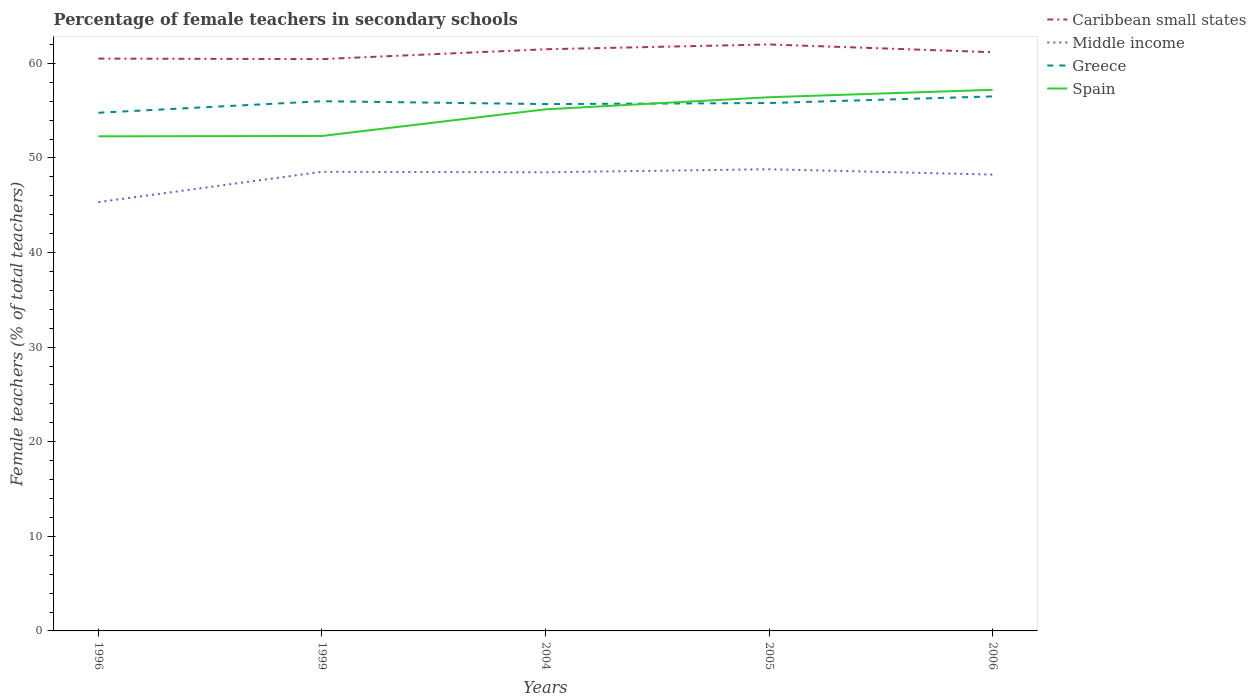Does the line corresponding to Greece intersect with the line corresponding to Spain?
Your answer should be very brief. Yes. Is the number of lines equal to the number of legend labels?
Make the answer very short. Yes. Across all years, what is the maximum percentage of female teachers in Caribbean small states?
Give a very brief answer. 60.45. In which year was the percentage of female teachers in Spain maximum?
Offer a very short reply. 1996. What is the total percentage of female teachers in Middle income in the graph?
Make the answer very short. 0.05. What is the difference between the highest and the second highest percentage of female teachers in Spain?
Make the answer very short. 4.92. What is the difference between the highest and the lowest percentage of female teachers in Middle income?
Your response must be concise. 4. Is the percentage of female teachers in Caribbean small states strictly greater than the percentage of female teachers in Spain over the years?
Your answer should be very brief. No. How many lines are there?
Provide a succinct answer. 4. How many years are there in the graph?
Offer a terse response. 5. Are the values on the major ticks of Y-axis written in scientific E-notation?
Keep it short and to the point. No. Does the graph contain any zero values?
Provide a succinct answer. No. Does the graph contain grids?
Ensure brevity in your answer.  No. How many legend labels are there?
Give a very brief answer. 4. How are the legend labels stacked?
Your answer should be compact. Vertical. What is the title of the graph?
Offer a very short reply. Percentage of female teachers in secondary schools. What is the label or title of the X-axis?
Your response must be concise. Years. What is the label or title of the Y-axis?
Your response must be concise. Female teachers (% of total teachers). What is the Female teachers (% of total teachers) in Caribbean small states in 1996?
Offer a terse response. 60.5. What is the Female teachers (% of total teachers) in Middle income in 1996?
Offer a very short reply. 45.33. What is the Female teachers (% of total teachers) in Greece in 1996?
Provide a succinct answer. 54.78. What is the Female teachers (% of total teachers) of Spain in 1996?
Offer a very short reply. 52.28. What is the Female teachers (% of total teachers) of Caribbean small states in 1999?
Ensure brevity in your answer.  60.45. What is the Female teachers (% of total teachers) in Middle income in 1999?
Keep it short and to the point. 48.54. What is the Female teachers (% of total teachers) in Greece in 1999?
Your answer should be very brief. 56. What is the Female teachers (% of total teachers) in Spain in 1999?
Offer a terse response. 52.32. What is the Female teachers (% of total teachers) of Caribbean small states in 2004?
Make the answer very short. 61.49. What is the Female teachers (% of total teachers) of Middle income in 2004?
Keep it short and to the point. 48.48. What is the Female teachers (% of total teachers) of Greece in 2004?
Your answer should be compact. 55.69. What is the Female teachers (% of total teachers) in Spain in 2004?
Your response must be concise. 55.14. What is the Female teachers (% of total teachers) in Caribbean small states in 2005?
Your answer should be very brief. 62. What is the Female teachers (% of total teachers) of Middle income in 2005?
Provide a short and direct response. 48.81. What is the Female teachers (% of total teachers) of Greece in 2005?
Make the answer very short. 55.8. What is the Female teachers (% of total teachers) of Spain in 2005?
Ensure brevity in your answer.  56.42. What is the Female teachers (% of total teachers) of Caribbean small states in 2006?
Your response must be concise. 61.18. What is the Female teachers (% of total teachers) in Middle income in 2006?
Give a very brief answer. 48.24. What is the Female teachers (% of total teachers) of Greece in 2006?
Keep it short and to the point. 56.5. What is the Female teachers (% of total teachers) in Spain in 2006?
Your answer should be very brief. 57.2. Across all years, what is the maximum Female teachers (% of total teachers) in Caribbean small states?
Make the answer very short. 62. Across all years, what is the maximum Female teachers (% of total teachers) of Middle income?
Ensure brevity in your answer.  48.81. Across all years, what is the maximum Female teachers (% of total teachers) in Greece?
Offer a very short reply. 56.5. Across all years, what is the maximum Female teachers (% of total teachers) of Spain?
Make the answer very short. 57.2. Across all years, what is the minimum Female teachers (% of total teachers) in Caribbean small states?
Give a very brief answer. 60.45. Across all years, what is the minimum Female teachers (% of total teachers) of Middle income?
Ensure brevity in your answer.  45.33. Across all years, what is the minimum Female teachers (% of total teachers) of Greece?
Make the answer very short. 54.78. Across all years, what is the minimum Female teachers (% of total teachers) in Spain?
Your answer should be compact. 52.28. What is the total Female teachers (% of total teachers) of Caribbean small states in the graph?
Offer a terse response. 305.61. What is the total Female teachers (% of total teachers) in Middle income in the graph?
Your response must be concise. 239.39. What is the total Female teachers (% of total teachers) in Greece in the graph?
Provide a short and direct response. 278.77. What is the total Female teachers (% of total teachers) of Spain in the graph?
Your response must be concise. 273.36. What is the difference between the Female teachers (% of total teachers) in Caribbean small states in 1996 and that in 1999?
Your answer should be compact. 0.05. What is the difference between the Female teachers (% of total teachers) in Middle income in 1996 and that in 1999?
Your answer should be very brief. -3.2. What is the difference between the Female teachers (% of total teachers) in Greece in 1996 and that in 1999?
Make the answer very short. -1.22. What is the difference between the Female teachers (% of total teachers) of Spain in 1996 and that in 1999?
Offer a terse response. -0.04. What is the difference between the Female teachers (% of total teachers) of Caribbean small states in 1996 and that in 2004?
Offer a terse response. -0.99. What is the difference between the Female teachers (% of total teachers) in Middle income in 1996 and that in 2004?
Your answer should be very brief. -3.15. What is the difference between the Female teachers (% of total teachers) in Greece in 1996 and that in 2004?
Keep it short and to the point. -0.92. What is the difference between the Female teachers (% of total teachers) in Spain in 1996 and that in 2004?
Provide a succinct answer. -2.85. What is the difference between the Female teachers (% of total teachers) of Caribbean small states in 1996 and that in 2005?
Offer a terse response. -1.5. What is the difference between the Female teachers (% of total teachers) in Middle income in 1996 and that in 2005?
Your answer should be compact. -3.48. What is the difference between the Female teachers (% of total teachers) of Greece in 1996 and that in 2005?
Make the answer very short. -1.03. What is the difference between the Female teachers (% of total teachers) of Spain in 1996 and that in 2005?
Provide a succinct answer. -4.13. What is the difference between the Female teachers (% of total teachers) of Caribbean small states in 1996 and that in 2006?
Make the answer very short. -0.68. What is the difference between the Female teachers (% of total teachers) in Middle income in 1996 and that in 2006?
Your response must be concise. -2.91. What is the difference between the Female teachers (% of total teachers) of Greece in 1996 and that in 2006?
Provide a short and direct response. -1.73. What is the difference between the Female teachers (% of total teachers) of Spain in 1996 and that in 2006?
Your response must be concise. -4.92. What is the difference between the Female teachers (% of total teachers) of Caribbean small states in 1999 and that in 2004?
Your answer should be very brief. -1.04. What is the difference between the Female teachers (% of total teachers) in Middle income in 1999 and that in 2004?
Offer a very short reply. 0.05. What is the difference between the Female teachers (% of total teachers) of Greece in 1999 and that in 2004?
Provide a short and direct response. 0.3. What is the difference between the Female teachers (% of total teachers) of Spain in 1999 and that in 2004?
Provide a short and direct response. -2.81. What is the difference between the Female teachers (% of total teachers) of Caribbean small states in 1999 and that in 2005?
Make the answer very short. -1.55. What is the difference between the Female teachers (% of total teachers) in Middle income in 1999 and that in 2005?
Provide a succinct answer. -0.27. What is the difference between the Female teachers (% of total teachers) in Greece in 1999 and that in 2005?
Make the answer very short. 0.19. What is the difference between the Female teachers (% of total teachers) in Spain in 1999 and that in 2005?
Keep it short and to the point. -4.09. What is the difference between the Female teachers (% of total teachers) in Caribbean small states in 1999 and that in 2006?
Your response must be concise. -0.73. What is the difference between the Female teachers (% of total teachers) in Middle income in 1999 and that in 2006?
Provide a short and direct response. 0.3. What is the difference between the Female teachers (% of total teachers) of Greece in 1999 and that in 2006?
Offer a very short reply. -0.51. What is the difference between the Female teachers (% of total teachers) in Spain in 1999 and that in 2006?
Provide a short and direct response. -4.88. What is the difference between the Female teachers (% of total teachers) of Caribbean small states in 2004 and that in 2005?
Keep it short and to the point. -0.51. What is the difference between the Female teachers (% of total teachers) of Middle income in 2004 and that in 2005?
Ensure brevity in your answer.  -0.32. What is the difference between the Female teachers (% of total teachers) in Greece in 2004 and that in 2005?
Give a very brief answer. -0.11. What is the difference between the Female teachers (% of total teachers) of Spain in 2004 and that in 2005?
Your answer should be compact. -1.28. What is the difference between the Female teachers (% of total teachers) of Caribbean small states in 2004 and that in 2006?
Provide a succinct answer. 0.31. What is the difference between the Female teachers (% of total teachers) of Middle income in 2004 and that in 2006?
Provide a short and direct response. 0.24. What is the difference between the Female teachers (% of total teachers) in Greece in 2004 and that in 2006?
Provide a succinct answer. -0.81. What is the difference between the Female teachers (% of total teachers) of Spain in 2004 and that in 2006?
Provide a succinct answer. -2.06. What is the difference between the Female teachers (% of total teachers) of Caribbean small states in 2005 and that in 2006?
Your response must be concise. 0.82. What is the difference between the Female teachers (% of total teachers) in Middle income in 2005 and that in 2006?
Give a very brief answer. 0.57. What is the difference between the Female teachers (% of total teachers) in Greece in 2005 and that in 2006?
Ensure brevity in your answer.  -0.7. What is the difference between the Female teachers (% of total teachers) in Spain in 2005 and that in 2006?
Your answer should be compact. -0.79. What is the difference between the Female teachers (% of total teachers) of Caribbean small states in 1996 and the Female teachers (% of total teachers) of Middle income in 1999?
Keep it short and to the point. 11.97. What is the difference between the Female teachers (% of total teachers) of Caribbean small states in 1996 and the Female teachers (% of total teachers) of Greece in 1999?
Provide a short and direct response. 4.5. What is the difference between the Female teachers (% of total teachers) of Caribbean small states in 1996 and the Female teachers (% of total teachers) of Spain in 1999?
Your answer should be very brief. 8.18. What is the difference between the Female teachers (% of total teachers) of Middle income in 1996 and the Female teachers (% of total teachers) of Greece in 1999?
Give a very brief answer. -10.67. What is the difference between the Female teachers (% of total teachers) in Middle income in 1996 and the Female teachers (% of total teachers) in Spain in 1999?
Ensure brevity in your answer.  -6.99. What is the difference between the Female teachers (% of total teachers) in Greece in 1996 and the Female teachers (% of total teachers) in Spain in 1999?
Keep it short and to the point. 2.45. What is the difference between the Female teachers (% of total teachers) of Caribbean small states in 1996 and the Female teachers (% of total teachers) of Middle income in 2004?
Keep it short and to the point. 12.02. What is the difference between the Female teachers (% of total teachers) of Caribbean small states in 1996 and the Female teachers (% of total teachers) of Greece in 2004?
Provide a short and direct response. 4.81. What is the difference between the Female teachers (% of total teachers) of Caribbean small states in 1996 and the Female teachers (% of total teachers) of Spain in 2004?
Your answer should be very brief. 5.36. What is the difference between the Female teachers (% of total teachers) of Middle income in 1996 and the Female teachers (% of total teachers) of Greece in 2004?
Give a very brief answer. -10.36. What is the difference between the Female teachers (% of total teachers) in Middle income in 1996 and the Female teachers (% of total teachers) in Spain in 2004?
Make the answer very short. -9.81. What is the difference between the Female teachers (% of total teachers) of Greece in 1996 and the Female teachers (% of total teachers) of Spain in 2004?
Offer a terse response. -0.36. What is the difference between the Female teachers (% of total teachers) in Caribbean small states in 1996 and the Female teachers (% of total teachers) in Middle income in 2005?
Your answer should be very brief. 11.7. What is the difference between the Female teachers (% of total teachers) in Caribbean small states in 1996 and the Female teachers (% of total teachers) in Greece in 2005?
Offer a very short reply. 4.7. What is the difference between the Female teachers (% of total teachers) in Caribbean small states in 1996 and the Female teachers (% of total teachers) in Spain in 2005?
Make the answer very short. 4.08. What is the difference between the Female teachers (% of total teachers) in Middle income in 1996 and the Female teachers (% of total teachers) in Greece in 2005?
Offer a very short reply. -10.47. What is the difference between the Female teachers (% of total teachers) of Middle income in 1996 and the Female teachers (% of total teachers) of Spain in 2005?
Ensure brevity in your answer.  -11.09. What is the difference between the Female teachers (% of total teachers) in Greece in 1996 and the Female teachers (% of total teachers) in Spain in 2005?
Your answer should be compact. -1.64. What is the difference between the Female teachers (% of total teachers) of Caribbean small states in 1996 and the Female teachers (% of total teachers) of Middle income in 2006?
Keep it short and to the point. 12.26. What is the difference between the Female teachers (% of total teachers) of Caribbean small states in 1996 and the Female teachers (% of total teachers) of Greece in 2006?
Provide a short and direct response. 4. What is the difference between the Female teachers (% of total teachers) of Caribbean small states in 1996 and the Female teachers (% of total teachers) of Spain in 2006?
Keep it short and to the point. 3.3. What is the difference between the Female teachers (% of total teachers) in Middle income in 1996 and the Female teachers (% of total teachers) in Greece in 2006?
Your response must be concise. -11.17. What is the difference between the Female teachers (% of total teachers) of Middle income in 1996 and the Female teachers (% of total teachers) of Spain in 2006?
Offer a very short reply. -11.87. What is the difference between the Female teachers (% of total teachers) in Greece in 1996 and the Female teachers (% of total teachers) in Spain in 2006?
Provide a succinct answer. -2.43. What is the difference between the Female teachers (% of total teachers) of Caribbean small states in 1999 and the Female teachers (% of total teachers) of Middle income in 2004?
Your answer should be compact. 11.97. What is the difference between the Female teachers (% of total teachers) in Caribbean small states in 1999 and the Female teachers (% of total teachers) in Greece in 2004?
Your answer should be compact. 4.76. What is the difference between the Female teachers (% of total teachers) in Caribbean small states in 1999 and the Female teachers (% of total teachers) in Spain in 2004?
Offer a terse response. 5.31. What is the difference between the Female teachers (% of total teachers) of Middle income in 1999 and the Female teachers (% of total teachers) of Greece in 2004?
Provide a succinct answer. -7.16. What is the difference between the Female teachers (% of total teachers) of Middle income in 1999 and the Female teachers (% of total teachers) of Spain in 2004?
Ensure brevity in your answer.  -6.6. What is the difference between the Female teachers (% of total teachers) in Greece in 1999 and the Female teachers (% of total teachers) in Spain in 2004?
Keep it short and to the point. 0.86. What is the difference between the Female teachers (% of total teachers) of Caribbean small states in 1999 and the Female teachers (% of total teachers) of Middle income in 2005?
Keep it short and to the point. 11.64. What is the difference between the Female teachers (% of total teachers) in Caribbean small states in 1999 and the Female teachers (% of total teachers) in Greece in 2005?
Your answer should be very brief. 4.64. What is the difference between the Female teachers (% of total teachers) in Caribbean small states in 1999 and the Female teachers (% of total teachers) in Spain in 2005?
Give a very brief answer. 4.03. What is the difference between the Female teachers (% of total teachers) of Middle income in 1999 and the Female teachers (% of total teachers) of Greece in 2005?
Offer a terse response. -7.27. What is the difference between the Female teachers (% of total teachers) of Middle income in 1999 and the Female teachers (% of total teachers) of Spain in 2005?
Make the answer very short. -7.88. What is the difference between the Female teachers (% of total teachers) of Greece in 1999 and the Female teachers (% of total teachers) of Spain in 2005?
Your response must be concise. -0.42. What is the difference between the Female teachers (% of total teachers) of Caribbean small states in 1999 and the Female teachers (% of total teachers) of Middle income in 2006?
Ensure brevity in your answer.  12.21. What is the difference between the Female teachers (% of total teachers) of Caribbean small states in 1999 and the Female teachers (% of total teachers) of Greece in 2006?
Your response must be concise. 3.94. What is the difference between the Female teachers (% of total teachers) in Caribbean small states in 1999 and the Female teachers (% of total teachers) in Spain in 2006?
Keep it short and to the point. 3.25. What is the difference between the Female teachers (% of total teachers) of Middle income in 1999 and the Female teachers (% of total teachers) of Greece in 2006?
Make the answer very short. -7.97. What is the difference between the Female teachers (% of total teachers) in Middle income in 1999 and the Female teachers (% of total teachers) in Spain in 2006?
Offer a terse response. -8.67. What is the difference between the Female teachers (% of total teachers) of Greece in 1999 and the Female teachers (% of total teachers) of Spain in 2006?
Your answer should be compact. -1.21. What is the difference between the Female teachers (% of total teachers) of Caribbean small states in 2004 and the Female teachers (% of total teachers) of Middle income in 2005?
Offer a very short reply. 12.68. What is the difference between the Female teachers (% of total teachers) in Caribbean small states in 2004 and the Female teachers (% of total teachers) in Greece in 2005?
Keep it short and to the point. 5.68. What is the difference between the Female teachers (% of total teachers) in Caribbean small states in 2004 and the Female teachers (% of total teachers) in Spain in 2005?
Provide a succinct answer. 5.07. What is the difference between the Female teachers (% of total teachers) of Middle income in 2004 and the Female teachers (% of total teachers) of Greece in 2005?
Keep it short and to the point. -7.32. What is the difference between the Female teachers (% of total teachers) of Middle income in 2004 and the Female teachers (% of total teachers) of Spain in 2005?
Provide a succinct answer. -7.93. What is the difference between the Female teachers (% of total teachers) of Greece in 2004 and the Female teachers (% of total teachers) of Spain in 2005?
Offer a terse response. -0.72. What is the difference between the Female teachers (% of total teachers) of Caribbean small states in 2004 and the Female teachers (% of total teachers) of Middle income in 2006?
Keep it short and to the point. 13.25. What is the difference between the Female teachers (% of total teachers) of Caribbean small states in 2004 and the Female teachers (% of total teachers) of Greece in 2006?
Make the answer very short. 4.98. What is the difference between the Female teachers (% of total teachers) in Caribbean small states in 2004 and the Female teachers (% of total teachers) in Spain in 2006?
Keep it short and to the point. 4.29. What is the difference between the Female teachers (% of total teachers) in Middle income in 2004 and the Female teachers (% of total teachers) in Greece in 2006?
Give a very brief answer. -8.02. What is the difference between the Female teachers (% of total teachers) in Middle income in 2004 and the Female teachers (% of total teachers) in Spain in 2006?
Make the answer very short. -8.72. What is the difference between the Female teachers (% of total teachers) in Greece in 2004 and the Female teachers (% of total teachers) in Spain in 2006?
Your answer should be very brief. -1.51. What is the difference between the Female teachers (% of total teachers) in Caribbean small states in 2005 and the Female teachers (% of total teachers) in Middle income in 2006?
Your answer should be very brief. 13.76. What is the difference between the Female teachers (% of total teachers) of Caribbean small states in 2005 and the Female teachers (% of total teachers) of Greece in 2006?
Offer a very short reply. 5.49. What is the difference between the Female teachers (% of total teachers) of Caribbean small states in 2005 and the Female teachers (% of total teachers) of Spain in 2006?
Offer a terse response. 4.79. What is the difference between the Female teachers (% of total teachers) of Middle income in 2005 and the Female teachers (% of total teachers) of Greece in 2006?
Your answer should be very brief. -7.7. What is the difference between the Female teachers (% of total teachers) of Middle income in 2005 and the Female teachers (% of total teachers) of Spain in 2006?
Offer a very short reply. -8.4. What is the difference between the Female teachers (% of total teachers) of Greece in 2005 and the Female teachers (% of total teachers) of Spain in 2006?
Provide a short and direct response. -1.4. What is the average Female teachers (% of total teachers) in Caribbean small states per year?
Keep it short and to the point. 61.12. What is the average Female teachers (% of total teachers) in Middle income per year?
Keep it short and to the point. 47.88. What is the average Female teachers (% of total teachers) in Greece per year?
Ensure brevity in your answer.  55.75. What is the average Female teachers (% of total teachers) in Spain per year?
Make the answer very short. 54.67. In the year 1996, what is the difference between the Female teachers (% of total teachers) in Caribbean small states and Female teachers (% of total teachers) in Middle income?
Make the answer very short. 15.17. In the year 1996, what is the difference between the Female teachers (% of total teachers) in Caribbean small states and Female teachers (% of total teachers) in Greece?
Provide a succinct answer. 5.72. In the year 1996, what is the difference between the Female teachers (% of total teachers) of Caribbean small states and Female teachers (% of total teachers) of Spain?
Provide a short and direct response. 8.22. In the year 1996, what is the difference between the Female teachers (% of total teachers) of Middle income and Female teachers (% of total teachers) of Greece?
Give a very brief answer. -9.45. In the year 1996, what is the difference between the Female teachers (% of total teachers) in Middle income and Female teachers (% of total teachers) in Spain?
Provide a short and direct response. -6.95. In the year 1996, what is the difference between the Female teachers (% of total teachers) in Greece and Female teachers (% of total teachers) in Spain?
Give a very brief answer. 2.49. In the year 1999, what is the difference between the Female teachers (% of total teachers) of Caribbean small states and Female teachers (% of total teachers) of Middle income?
Offer a terse response. 11.91. In the year 1999, what is the difference between the Female teachers (% of total teachers) of Caribbean small states and Female teachers (% of total teachers) of Greece?
Your response must be concise. 4.45. In the year 1999, what is the difference between the Female teachers (% of total teachers) of Caribbean small states and Female teachers (% of total teachers) of Spain?
Your answer should be compact. 8.12. In the year 1999, what is the difference between the Female teachers (% of total teachers) of Middle income and Female teachers (% of total teachers) of Greece?
Your answer should be compact. -7.46. In the year 1999, what is the difference between the Female teachers (% of total teachers) in Middle income and Female teachers (% of total teachers) in Spain?
Provide a succinct answer. -3.79. In the year 1999, what is the difference between the Female teachers (% of total teachers) of Greece and Female teachers (% of total teachers) of Spain?
Give a very brief answer. 3.67. In the year 2004, what is the difference between the Female teachers (% of total teachers) in Caribbean small states and Female teachers (% of total teachers) in Middle income?
Provide a succinct answer. 13.01. In the year 2004, what is the difference between the Female teachers (% of total teachers) of Caribbean small states and Female teachers (% of total teachers) of Greece?
Give a very brief answer. 5.8. In the year 2004, what is the difference between the Female teachers (% of total teachers) in Caribbean small states and Female teachers (% of total teachers) in Spain?
Provide a succinct answer. 6.35. In the year 2004, what is the difference between the Female teachers (% of total teachers) of Middle income and Female teachers (% of total teachers) of Greece?
Your answer should be very brief. -7.21. In the year 2004, what is the difference between the Female teachers (% of total teachers) in Middle income and Female teachers (% of total teachers) in Spain?
Ensure brevity in your answer.  -6.66. In the year 2004, what is the difference between the Female teachers (% of total teachers) of Greece and Female teachers (% of total teachers) of Spain?
Offer a very short reply. 0.55. In the year 2005, what is the difference between the Female teachers (% of total teachers) of Caribbean small states and Female teachers (% of total teachers) of Middle income?
Offer a terse response. 13.19. In the year 2005, what is the difference between the Female teachers (% of total teachers) of Caribbean small states and Female teachers (% of total teachers) of Greece?
Offer a terse response. 6.19. In the year 2005, what is the difference between the Female teachers (% of total teachers) of Caribbean small states and Female teachers (% of total teachers) of Spain?
Provide a short and direct response. 5.58. In the year 2005, what is the difference between the Female teachers (% of total teachers) of Middle income and Female teachers (% of total teachers) of Greece?
Your response must be concise. -7. In the year 2005, what is the difference between the Female teachers (% of total teachers) in Middle income and Female teachers (% of total teachers) in Spain?
Make the answer very short. -7.61. In the year 2005, what is the difference between the Female teachers (% of total teachers) of Greece and Female teachers (% of total teachers) of Spain?
Provide a succinct answer. -0.61. In the year 2006, what is the difference between the Female teachers (% of total teachers) in Caribbean small states and Female teachers (% of total teachers) in Middle income?
Make the answer very short. 12.94. In the year 2006, what is the difference between the Female teachers (% of total teachers) in Caribbean small states and Female teachers (% of total teachers) in Greece?
Make the answer very short. 4.67. In the year 2006, what is the difference between the Female teachers (% of total teachers) of Caribbean small states and Female teachers (% of total teachers) of Spain?
Your answer should be very brief. 3.98. In the year 2006, what is the difference between the Female teachers (% of total teachers) in Middle income and Female teachers (% of total teachers) in Greece?
Offer a terse response. -8.27. In the year 2006, what is the difference between the Female teachers (% of total teachers) of Middle income and Female teachers (% of total teachers) of Spain?
Offer a terse response. -8.96. In the year 2006, what is the difference between the Female teachers (% of total teachers) of Greece and Female teachers (% of total teachers) of Spain?
Keep it short and to the point. -0.7. What is the ratio of the Female teachers (% of total teachers) in Middle income in 1996 to that in 1999?
Your answer should be very brief. 0.93. What is the ratio of the Female teachers (% of total teachers) of Greece in 1996 to that in 1999?
Provide a short and direct response. 0.98. What is the ratio of the Female teachers (% of total teachers) of Caribbean small states in 1996 to that in 2004?
Your answer should be compact. 0.98. What is the ratio of the Female teachers (% of total teachers) in Middle income in 1996 to that in 2004?
Offer a terse response. 0.94. What is the ratio of the Female teachers (% of total teachers) of Greece in 1996 to that in 2004?
Your answer should be compact. 0.98. What is the ratio of the Female teachers (% of total teachers) in Spain in 1996 to that in 2004?
Keep it short and to the point. 0.95. What is the ratio of the Female teachers (% of total teachers) in Caribbean small states in 1996 to that in 2005?
Make the answer very short. 0.98. What is the ratio of the Female teachers (% of total teachers) in Middle income in 1996 to that in 2005?
Ensure brevity in your answer.  0.93. What is the ratio of the Female teachers (% of total teachers) of Greece in 1996 to that in 2005?
Provide a short and direct response. 0.98. What is the ratio of the Female teachers (% of total teachers) of Spain in 1996 to that in 2005?
Your answer should be compact. 0.93. What is the ratio of the Female teachers (% of total teachers) in Caribbean small states in 1996 to that in 2006?
Ensure brevity in your answer.  0.99. What is the ratio of the Female teachers (% of total teachers) of Middle income in 1996 to that in 2006?
Offer a terse response. 0.94. What is the ratio of the Female teachers (% of total teachers) of Greece in 1996 to that in 2006?
Offer a very short reply. 0.97. What is the ratio of the Female teachers (% of total teachers) of Spain in 1996 to that in 2006?
Your answer should be compact. 0.91. What is the ratio of the Female teachers (% of total teachers) of Caribbean small states in 1999 to that in 2004?
Your response must be concise. 0.98. What is the ratio of the Female teachers (% of total teachers) in Greece in 1999 to that in 2004?
Your answer should be compact. 1.01. What is the ratio of the Female teachers (% of total teachers) of Spain in 1999 to that in 2004?
Offer a terse response. 0.95. What is the ratio of the Female teachers (% of total teachers) of Caribbean small states in 1999 to that in 2005?
Your response must be concise. 0.97. What is the ratio of the Female teachers (% of total teachers) in Middle income in 1999 to that in 2005?
Make the answer very short. 0.99. What is the ratio of the Female teachers (% of total teachers) of Greece in 1999 to that in 2005?
Offer a very short reply. 1. What is the ratio of the Female teachers (% of total teachers) in Spain in 1999 to that in 2005?
Your answer should be compact. 0.93. What is the ratio of the Female teachers (% of total teachers) in Caribbean small states in 1999 to that in 2006?
Make the answer very short. 0.99. What is the ratio of the Female teachers (% of total teachers) in Greece in 1999 to that in 2006?
Provide a short and direct response. 0.99. What is the ratio of the Female teachers (% of total teachers) in Spain in 1999 to that in 2006?
Offer a terse response. 0.91. What is the ratio of the Female teachers (% of total teachers) of Middle income in 2004 to that in 2005?
Your answer should be compact. 0.99. What is the ratio of the Female teachers (% of total teachers) of Greece in 2004 to that in 2005?
Give a very brief answer. 1. What is the ratio of the Female teachers (% of total teachers) of Spain in 2004 to that in 2005?
Provide a short and direct response. 0.98. What is the ratio of the Female teachers (% of total teachers) of Caribbean small states in 2004 to that in 2006?
Make the answer very short. 1.01. What is the ratio of the Female teachers (% of total teachers) in Middle income in 2004 to that in 2006?
Your answer should be compact. 1. What is the ratio of the Female teachers (% of total teachers) of Greece in 2004 to that in 2006?
Give a very brief answer. 0.99. What is the ratio of the Female teachers (% of total teachers) of Spain in 2004 to that in 2006?
Keep it short and to the point. 0.96. What is the ratio of the Female teachers (% of total teachers) of Caribbean small states in 2005 to that in 2006?
Ensure brevity in your answer.  1.01. What is the ratio of the Female teachers (% of total teachers) in Middle income in 2005 to that in 2006?
Offer a terse response. 1.01. What is the ratio of the Female teachers (% of total teachers) of Greece in 2005 to that in 2006?
Make the answer very short. 0.99. What is the ratio of the Female teachers (% of total teachers) of Spain in 2005 to that in 2006?
Keep it short and to the point. 0.99. What is the difference between the highest and the second highest Female teachers (% of total teachers) of Caribbean small states?
Make the answer very short. 0.51. What is the difference between the highest and the second highest Female teachers (% of total teachers) in Middle income?
Offer a terse response. 0.27. What is the difference between the highest and the second highest Female teachers (% of total teachers) in Greece?
Offer a very short reply. 0.51. What is the difference between the highest and the second highest Female teachers (% of total teachers) in Spain?
Provide a short and direct response. 0.79. What is the difference between the highest and the lowest Female teachers (% of total teachers) in Caribbean small states?
Offer a very short reply. 1.55. What is the difference between the highest and the lowest Female teachers (% of total teachers) in Middle income?
Offer a terse response. 3.48. What is the difference between the highest and the lowest Female teachers (% of total teachers) of Greece?
Give a very brief answer. 1.73. What is the difference between the highest and the lowest Female teachers (% of total teachers) of Spain?
Offer a terse response. 4.92. 